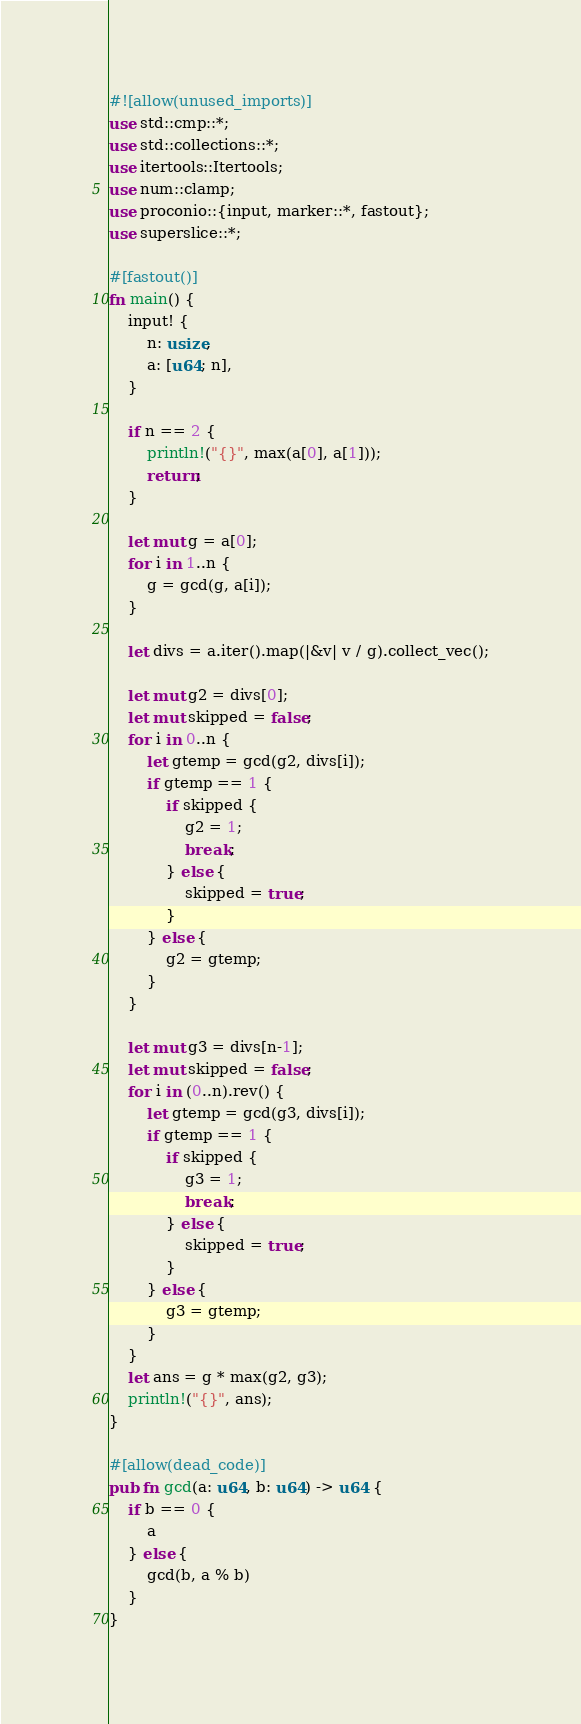<code> <loc_0><loc_0><loc_500><loc_500><_Rust_>#![allow(unused_imports)]
use std::cmp::*;
use std::collections::*;
use itertools::Itertools;
use num::clamp;
use proconio::{input, marker::*, fastout};
use superslice::*;

#[fastout()]
fn main() {
    input! {
        n: usize,
        a: [u64; n],
    }

    if n == 2 {
        println!("{}", max(a[0], a[1]));
        return;
    }

    let mut g = a[0];
    for i in 1..n {
        g = gcd(g, a[i]);
    }
    
    let divs = a.iter().map(|&v| v / g).collect_vec();

    let mut g2 = divs[0];
    let mut skipped = false;
    for i in 0..n {
        let gtemp = gcd(g2, divs[i]);
        if gtemp == 1 {
            if skipped {
                g2 = 1;
                break;
            } else {
                skipped = true;
            }
        } else {
            g2 = gtemp;
        }
    }

    let mut g3 = divs[n-1];
    let mut skipped = false;
    for i in (0..n).rev() {
        let gtemp = gcd(g3, divs[i]);
        if gtemp == 1 {
            if skipped {
                g3 = 1;
                break;
            } else {
                skipped = true;
            }
        } else {
            g3 = gtemp;
        }
    }
    let ans = g * max(g2, g3);
    println!("{}", ans);
}

#[allow(dead_code)]
pub fn gcd(a: u64, b: u64) -> u64 {
    if b == 0 {
        a
    } else {
        gcd(b, a % b)
    }
}</code> 